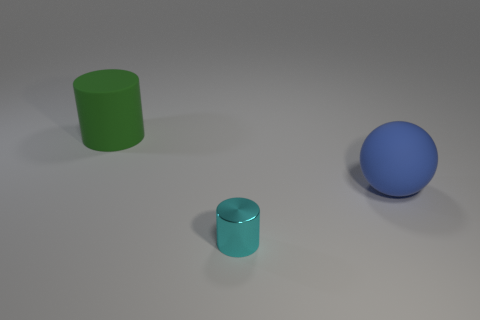Add 1 tiny metal cylinders. How many objects exist? 4 Subtract all cylinders. How many objects are left? 1 Add 3 gray shiny balls. How many gray shiny balls exist? 3 Subtract 1 cyan cylinders. How many objects are left? 2 Subtract all tiny cyan cylinders. Subtract all small green rubber things. How many objects are left? 2 Add 2 cylinders. How many cylinders are left? 4 